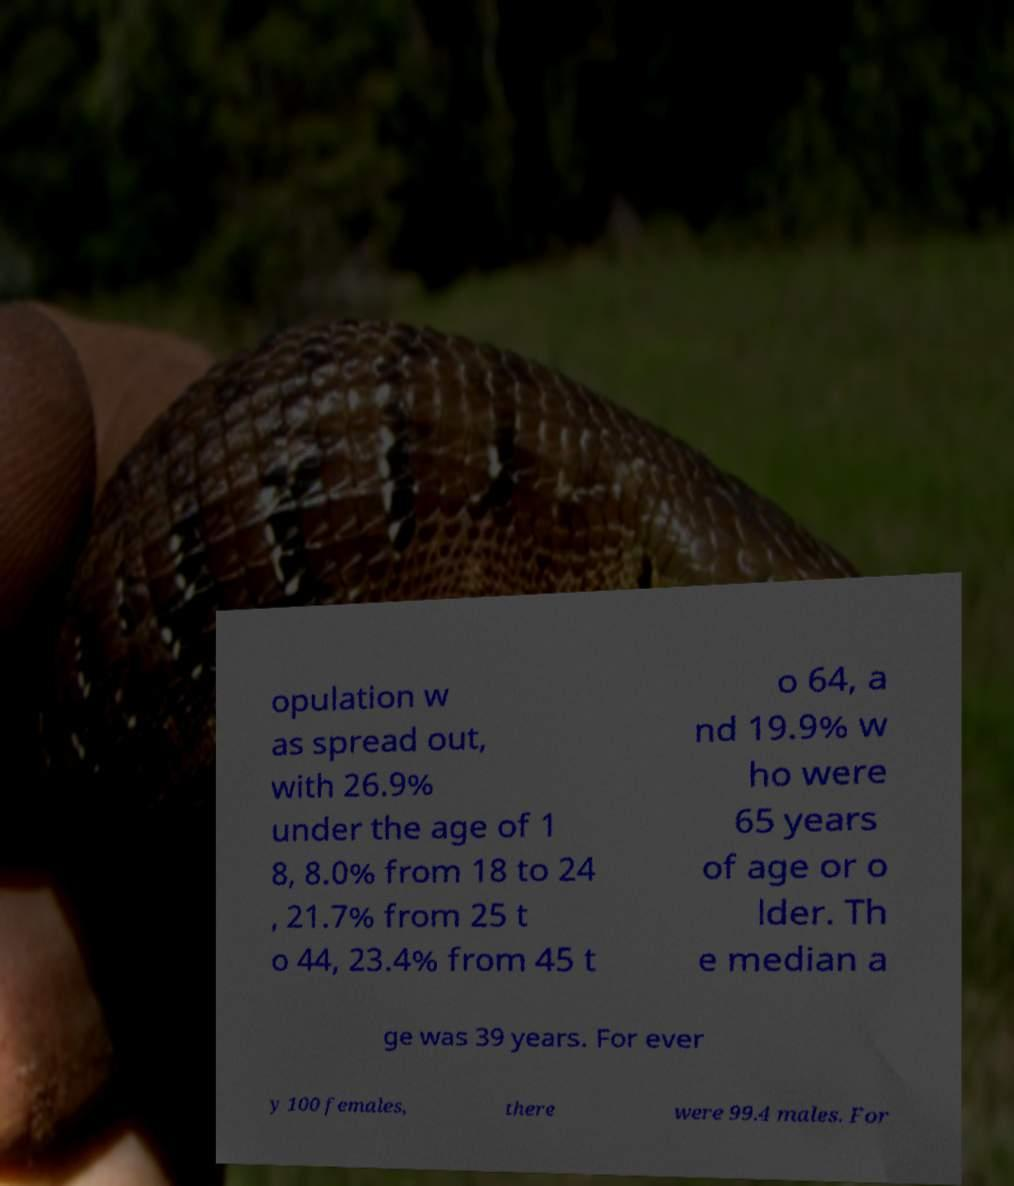Can you accurately transcribe the text from the provided image for me? opulation w as spread out, with 26.9% under the age of 1 8, 8.0% from 18 to 24 , 21.7% from 25 t o 44, 23.4% from 45 t o 64, a nd 19.9% w ho were 65 years of age or o lder. Th e median a ge was 39 years. For ever y 100 females, there were 99.4 males. For 